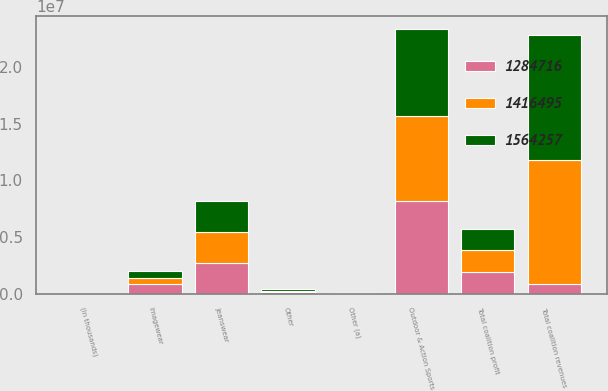<chart> <loc_0><loc_0><loc_500><loc_500><stacked_bar_chart><ecel><fcel>(In thousands)<fcel>Outdoor & Action Sports<fcel>Jeanswear<fcel>Imagewear<fcel>Other<fcel>Total coalition revenues<fcel>Other (a)<fcel>Total coalition profit<nl><fcel>1.28472e+06<fcel>2017<fcel>8.21246e+06<fcel>2.65536e+06<fcel>830215<fcel>113145<fcel>830215<fcel>3086<fcel>1.9104e+06<nl><fcel>1.56426e+06<fcel>2016<fcel>7.61856e+06<fcel>2.7377e+06<fcel>551808<fcel>118074<fcel>1.10261e+07<fcel>4817<fcel>1.83432e+06<nl><fcel>1.4165e+06<fcel>2015<fcel>7.49279e+06<fcel>2.79224e+06<fcel>577462<fcel>133898<fcel>1.09964e+07<fcel>14979<fcel>1.9451e+06<nl></chart> 